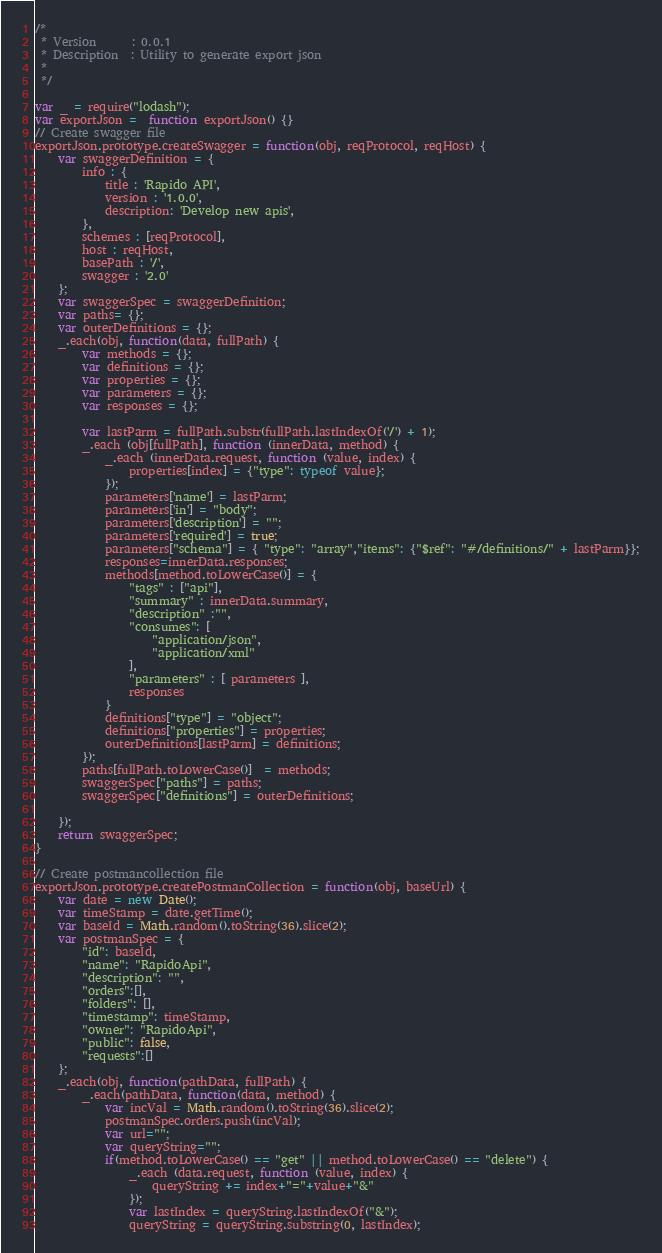Convert code to text. <code><loc_0><loc_0><loc_500><loc_500><_JavaScript_>/*
 * Version		: 0.0.1
 * Description	: Utility to generate export json
 *
 */

var _ = require("lodash");
var exportJson =  function exportJson() {}
// Create swagger file
exportJson.prototype.createSwagger = function(obj, reqProtocol, reqHost) {
    var swaggerDefinition = {
        info : {
            title : 'Rapido API',
            version : '1.0.0',
            description: 'Develop new apis',
        },
        schemes : [reqProtocol],
        host : reqHost,
        basePath : '/',
        swagger : '2.0'
    };
    var swaggerSpec = swaggerDefinition;
    var paths= {};
    var outerDefinitions = {};
    _.each(obj, function(data, fullPath) {
        var methods = {};
        var definitions = {};
        var properties = {};
        var parameters = {};
        var responses = {};

        var lastParm = fullPath.substr(fullPath.lastIndexOf('/') + 1);
        _.each (obj[fullPath], function (innerData, method) {
            _.each (innerData.request, function (value, index) {
                properties[index] = {"type": typeof value};
            });
            parameters['name'] = lastParm;
            parameters['in'] = "body";
            parameters['description'] = "";
            parameters['required'] = true;
            parameters["schema"] = { "type": "array","items": {"$ref": "#/definitions/" + lastParm}};
            responses=innerData.responses;
            methods[method.toLowerCase()] = {
                "tags" : ["api"],
                "summary" : innerData.summary,
                "description" :"",
                "consumes": [
                    "application/json",
                    "application/xml"
                ],
                "parameters" : [ parameters ],
                responses
            }
            definitions["type"] = "object";
            definitions["properties"] = properties;
            outerDefinitions[lastParm] = definitions;
        });
        paths[fullPath.toLowerCase()]  = methods;
        swaggerSpec["paths"] = paths;
        swaggerSpec["definitions"] = outerDefinitions;

    });
    return swaggerSpec;
}

// Create postmancollection file
exportJson.prototype.createPostmanCollection = function(obj, baseUrl) {
    var date = new Date();
    var timeStamp = date.getTime();
    var baseId = Math.random().toString(36).slice(2);
    var postmanSpec = {
        "id": baseId,
        "name": "RapidoApi",
        "description": "",
        "orders":[],
        "folders": [],
        "timestamp": timeStamp,
        "owner": "RapidoApi",
        "public": false,
        "requests":[]
    };
    _.each(obj, function(pathData, fullPath) {
        _.each(pathData, function(data, method) {
            var incVal = Math.random().toString(36).slice(2);
            postmanSpec.orders.push(incVal);
            var url="";
            var queryString="";
            if(method.toLowerCase() == "get" || method.toLowerCase() == "delete") {
                _.each (data.request, function (value, index) {
                    queryString += index+"="+value+"&"
                });
                var lastIndex = queryString.lastIndexOf("&");
                queryString = queryString.substring(0, lastIndex);</code> 